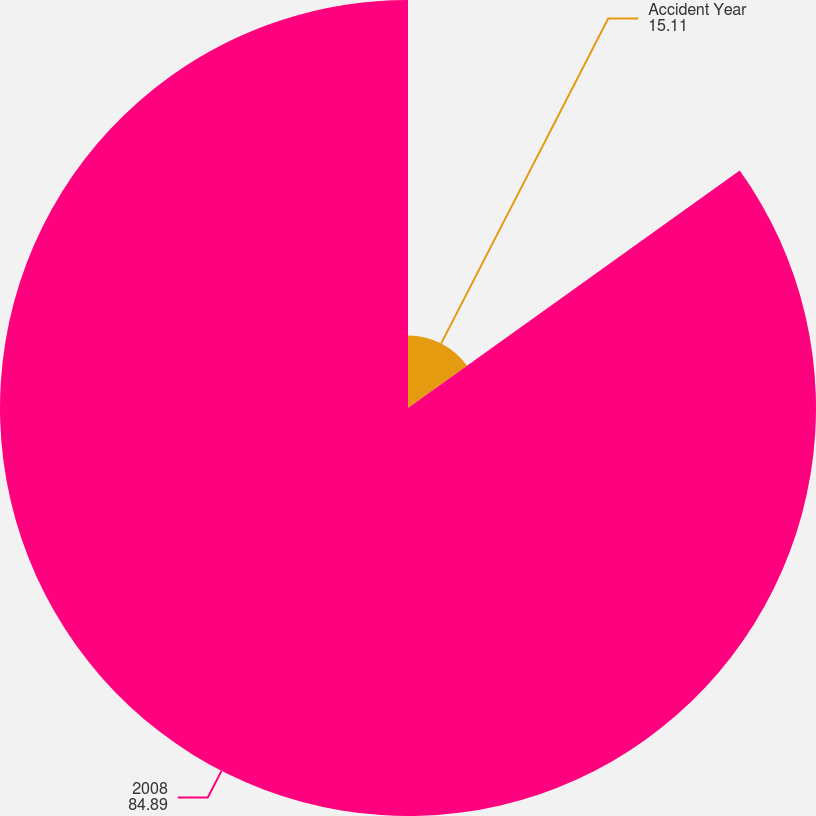Convert chart to OTSL. <chart><loc_0><loc_0><loc_500><loc_500><pie_chart><fcel>Accident Year<fcel>2008<nl><fcel>15.11%<fcel>84.89%<nl></chart> 